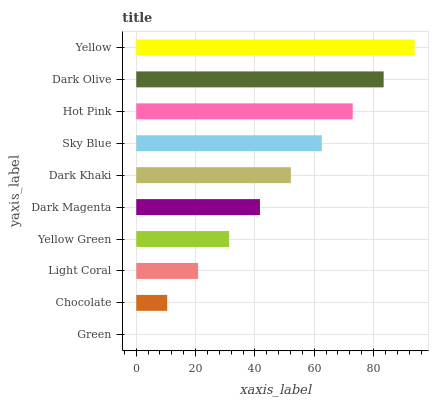Is Green the minimum?
Answer yes or no. Yes. Is Yellow the maximum?
Answer yes or no. Yes. Is Chocolate the minimum?
Answer yes or no. No. Is Chocolate the maximum?
Answer yes or no. No. Is Chocolate greater than Green?
Answer yes or no. Yes. Is Green less than Chocolate?
Answer yes or no. Yes. Is Green greater than Chocolate?
Answer yes or no. No. Is Chocolate less than Green?
Answer yes or no. No. Is Dark Khaki the high median?
Answer yes or no. Yes. Is Dark Magenta the low median?
Answer yes or no. Yes. Is Dark Olive the high median?
Answer yes or no. No. Is Hot Pink the low median?
Answer yes or no. No. 